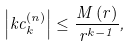Convert formula to latex. <formula><loc_0><loc_0><loc_500><loc_500>\left | k c _ { k } ^ { \left ( n \right ) } \right | \leq \frac { M \left ( r \right ) } { r ^ { k - 1 } } ,</formula> 